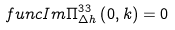<formula> <loc_0><loc_0><loc_500><loc_500>\ f u n c { I m } \Pi _ { \Delta h } ^ { 3 3 } \left ( 0 , k \right ) = 0</formula> 